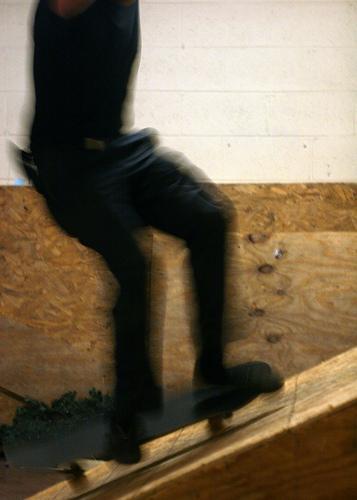How many people are there?
Give a very brief answer. 1. 